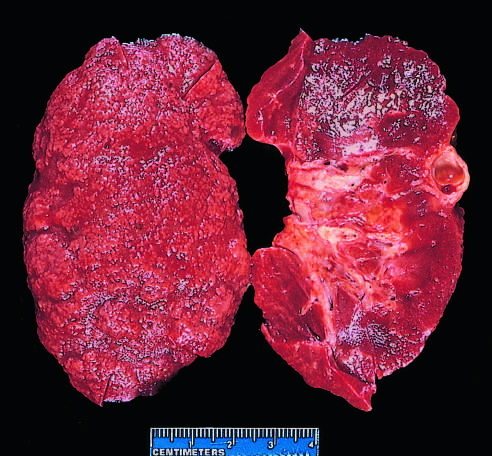do additional features include some irregular depressions, the result of pyelonephritis, and an incidental cortical cyst far right?
Answer the question using a single word or phrase. Yes 